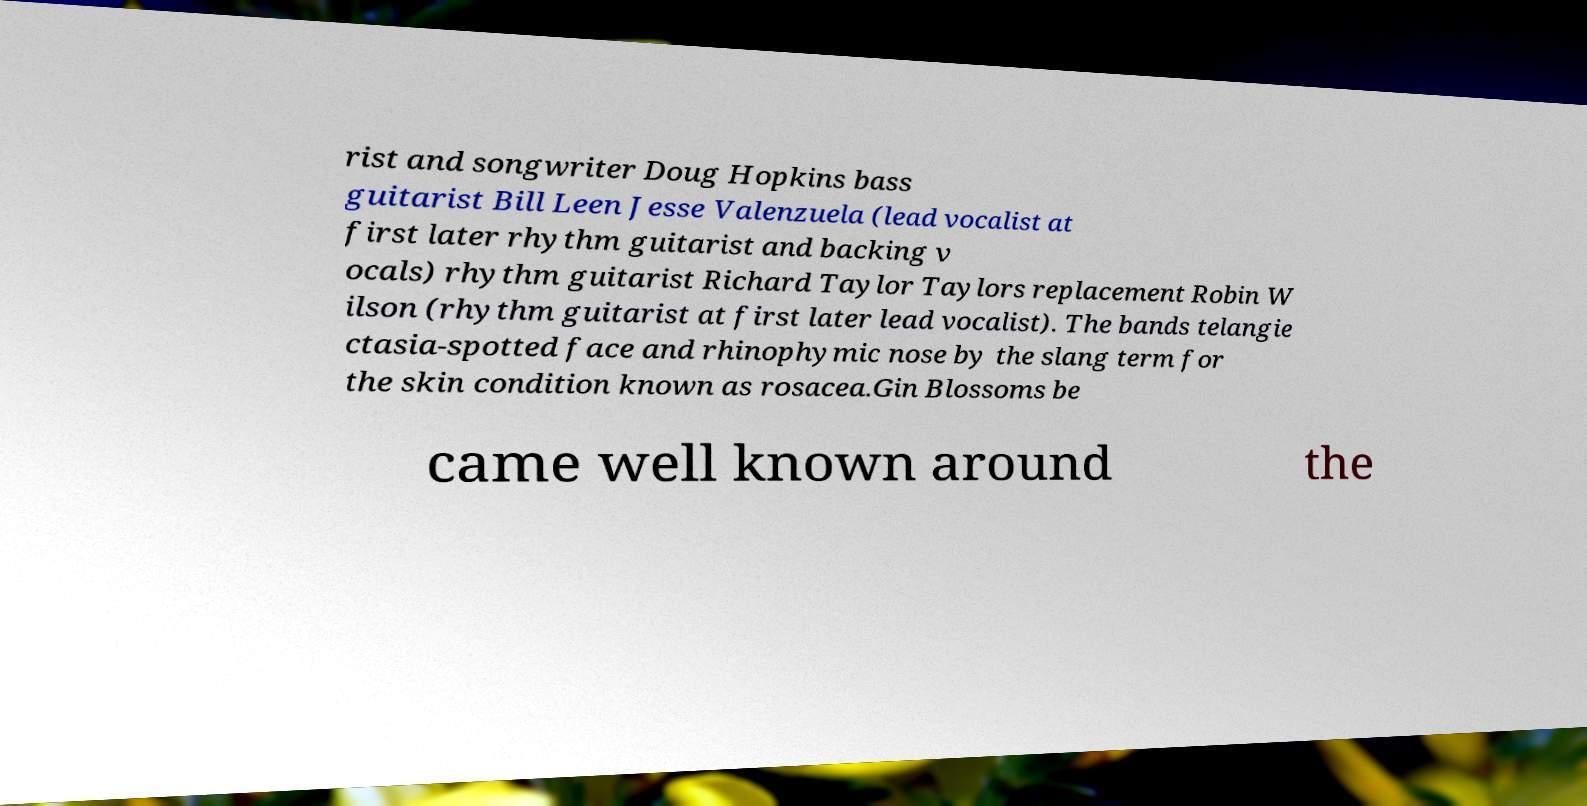Please identify and transcribe the text found in this image. rist and songwriter Doug Hopkins bass guitarist Bill Leen Jesse Valenzuela (lead vocalist at first later rhythm guitarist and backing v ocals) rhythm guitarist Richard Taylor Taylors replacement Robin W ilson (rhythm guitarist at first later lead vocalist). The bands telangie ctasia-spotted face and rhinophymic nose by the slang term for the skin condition known as rosacea.Gin Blossoms be came well known around the 